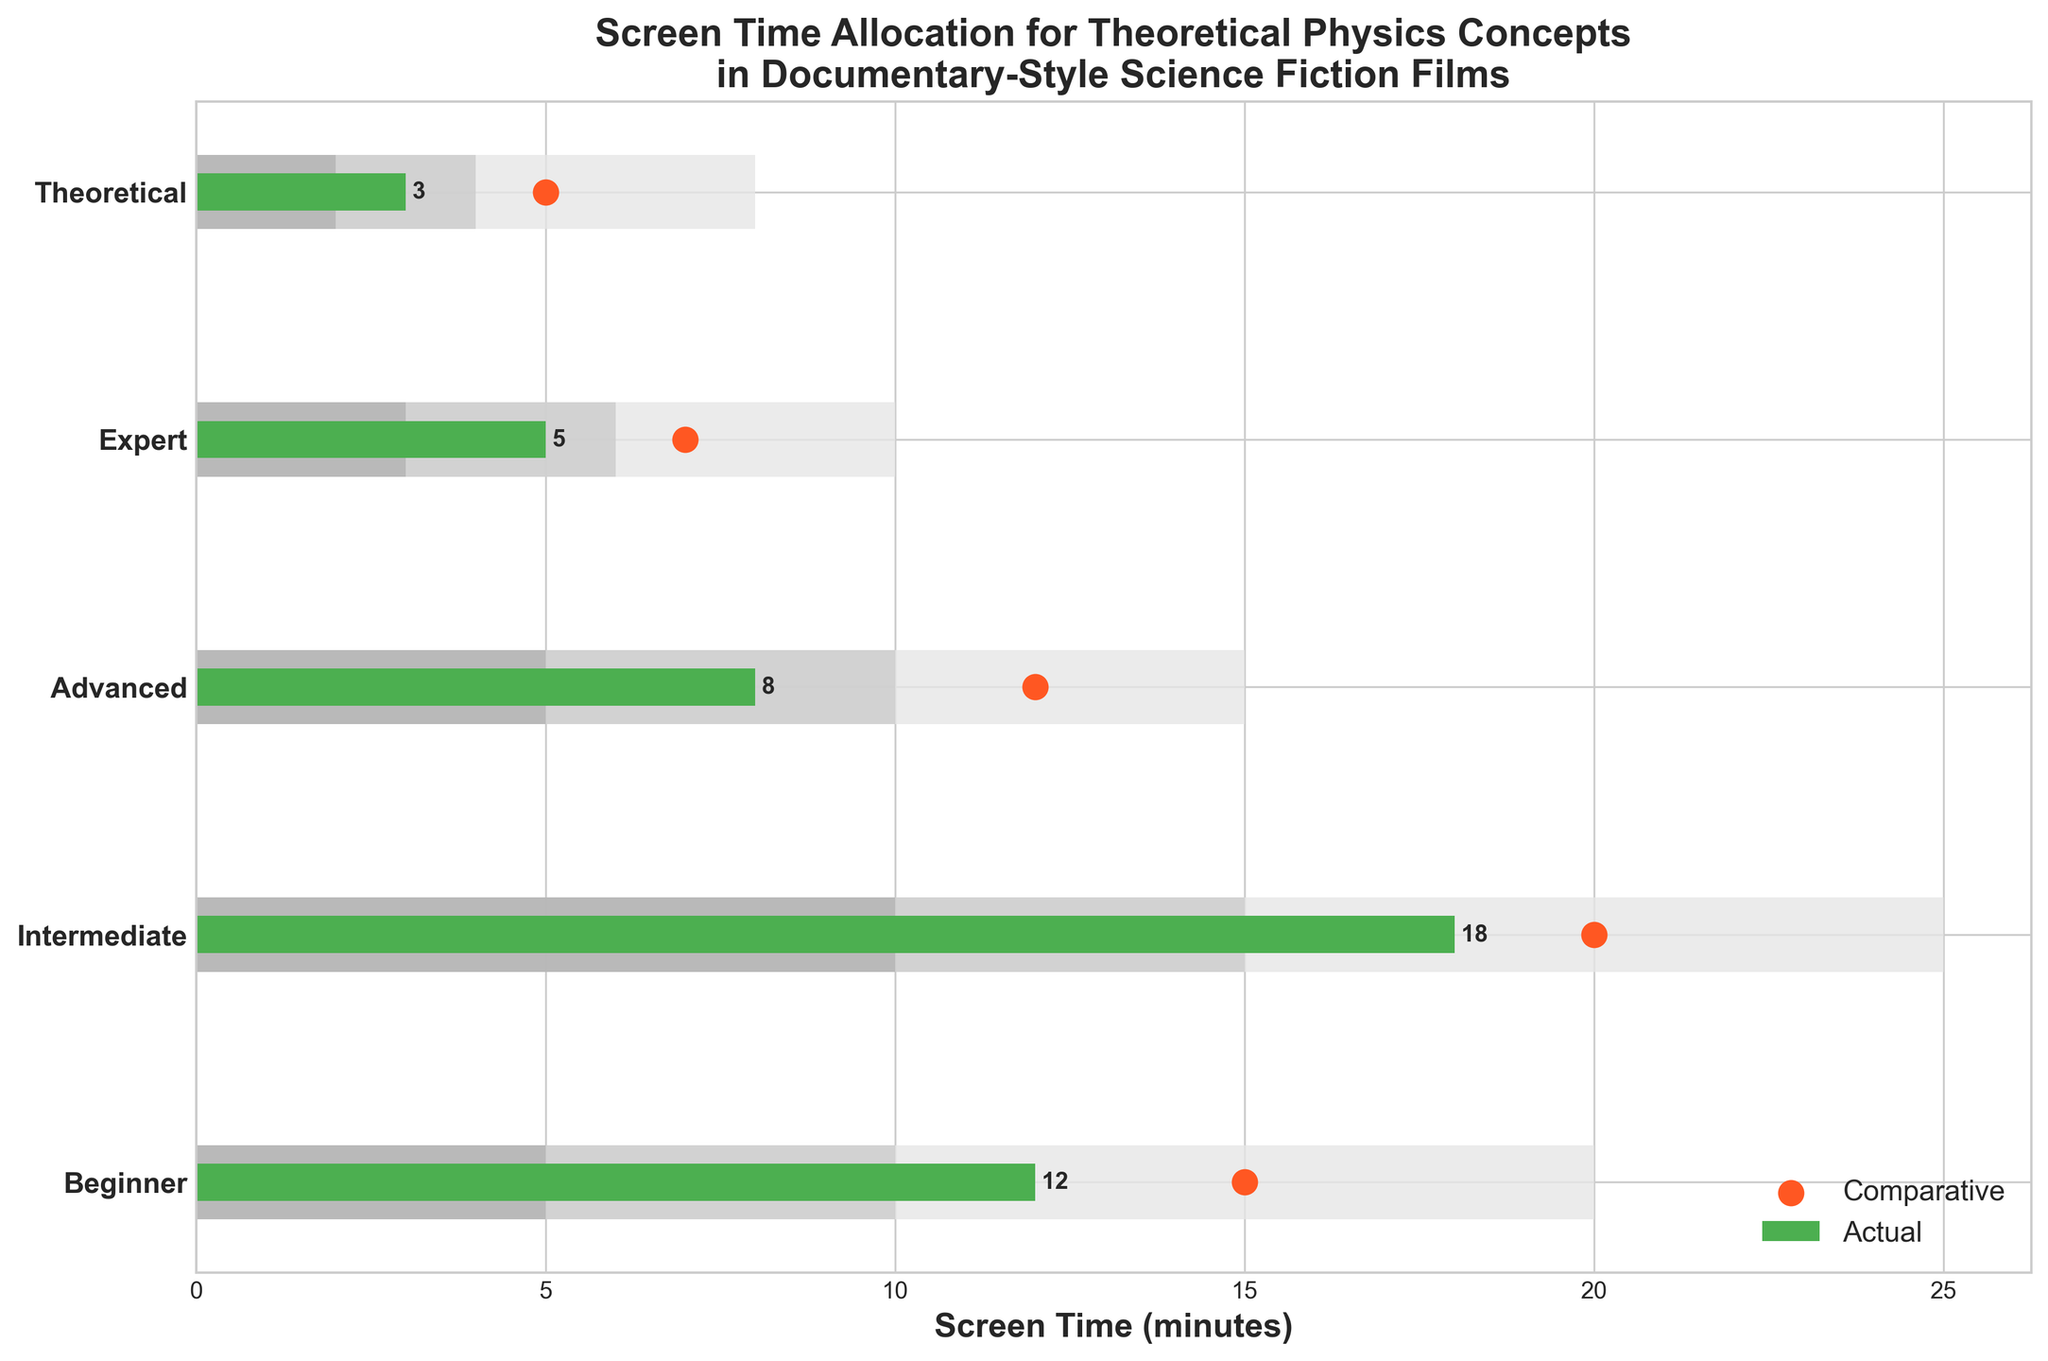What's the title of the figure? The title can be found at the top of the figure.
Answer: Screen Time Allocation for Theoretical Physics Concepts in Documentary-Style Science Fiction Films Which complexity level has the highest actual screen time? By examining the actual values for each complexity level, the highest one is 18 minutes.
Answer: Intermediate What is the difference in actual screen time between the Beginner and Expert categories? The actual screen time for Beginner is 12 minutes and for Expert is 5 minutes. The difference is 12 - 5 = 7 minutes.
Answer: 7 minutes Which category has the smallest gap between actual and comparative screen time? The gaps are: Beginner (3), Intermediate (2), Advanced (4), Expert (2), Theoretical (2). The smallest gap is 2, found in the Intermediate, Expert, and Theoretical categories.
Answer: Intermediate, Expert, Theoretical For which complexity levels does the actual screen time fall within the middle range? The middle ranges are: Beginner (5-10), Intermediate (10-15), Advanced (5-10), Expert (3-6), Theoretical (2-4). Checking where the actual screen time falls within these ranges: Intermediate, Expert, and Theoretical.
Answer: Intermediate, Expert, Theoretical How many categories have their actual screen time below their lowest comparative range value? None of the categories have an actual screen time lower than their lowest comparative range value. All actual screen times are within or above their comparative ranges.
Answer: None What's the total screen time for all actual values combined? Sum the actual screen times for all categories: 12 + 18 + 8 + 5 + 3 = 46 minutes.
Answer: 46 minutes Which categories have comparative screen times that exceed the highest ranges? The comparative values are: Beginner (15), Intermediate (20), Advanced (12), Expert (7), Theoretical (5). Only Beginner exceeds its highest range (20 minutes) with 15 minutes.
Answer: None By how many minutes does the Expert category's actual screen time fall short of the Expert category's highest range value? The actual screen time for Expert is 5 minutes and the highest range value is 10. The shortfall is 10 - 5 = 5 minutes.
Answer: 5 minutes 